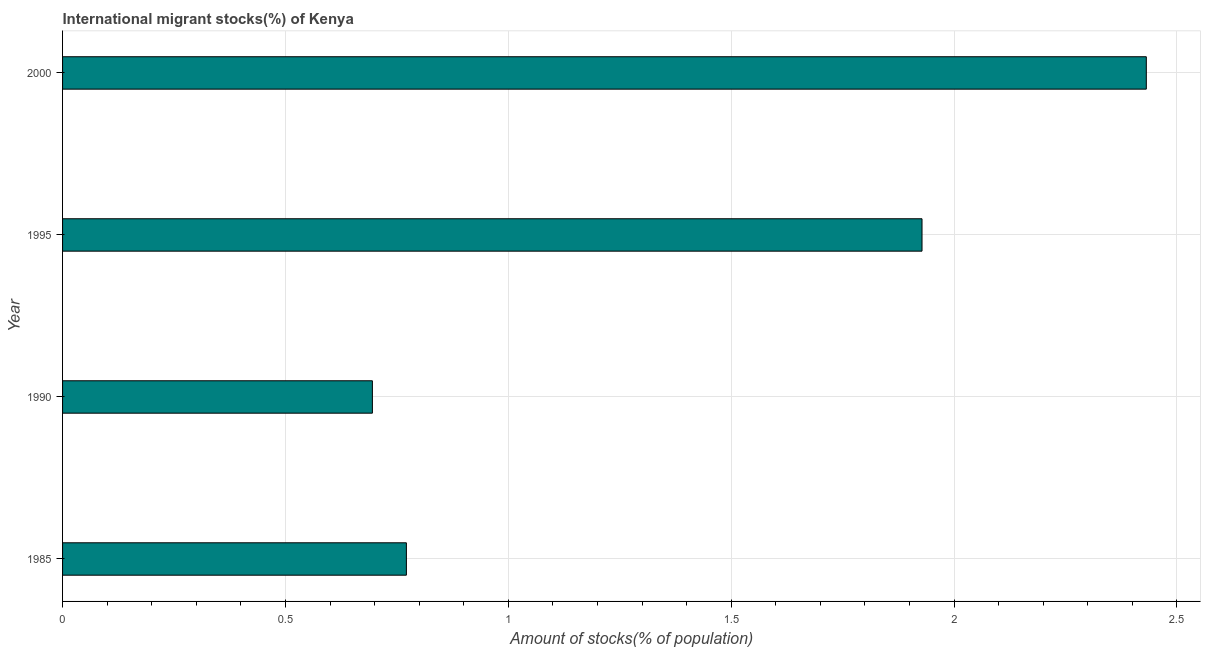Does the graph contain any zero values?
Keep it short and to the point. No. Does the graph contain grids?
Ensure brevity in your answer.  Yes. What is the title of the graph?
Offer a terse response. International migrant stocks(%) of Kenya. What is the label or title of the X-axis?
Ensure brevity in your answer.  Amount of stocks(% of population). What is the label or title of the Y-axis?
Provide a succinct answer. Year. What is the number of international migrant stocks in 1990?
Your answer should be compact. 0.7. Across all years, what is the maximum number of international migrant stocks?
Make the answer very short. 2.43. Across all years, what is the minimum number of international migrant stocks?
Keep it short and to the point. 0.7. In which year was the number of international migrant stocks maximum?
Make the answer very short. 2000. What is the sum of the number of international migrant stocks?
Provide a succinct answer. 5.83. What is the difference between the number of international migrant stocks in 1985 and 1995?
Offer a terse response. -1.16. What is the average number of international migrant stocks per year?
Offer a terse response. 1.46. What is the median number of international migrant stocks?
Make the answer very short. 1.35. In how many years, is the number of international migrant stocks greater than 2.3 %?
Offer a very short reply. 1. Do a majority of the years between 2000 and 1985 (inclusive) have number of international migrant stocks greater than 1.6 %?
Make the answer very short. Yes. What is the ratio of the number of international migrant stocks in 1985 to that in 1990?
Make the answer very short. 1.11. Is the number of international migrant stocks in 1985 less than that in 2000?
Ensure brevity in your answer.  Yes. What is the difference between the highest and the second highest number of international migrant stocks?
Make the answer very short. 0.5. Is the sum of the number of international migrant stocks in 1990 and 1995 greater than the maximum number of international migrant stocks across all years?
Your answer should be compact. Yes. What is the difference between the highest and the lowest number of international migrant stocks?
Your answer should be compact. 1.74. In how many years, is the number of international migrant stocks greater than the average number of international migrant stocks taken over all years?
Ensure brevity in your answer.  2. Are all the bars in the graph horizontal?
Make the answer very short. Yes. What is the Amount of stocks(% of population) in 1985?
Your answer should be very brief. 0.77. What is the Amount of stocks(% of population) in 1990?
Your answer should be very brief. 0.7. What is the Amount of stocks(% of population) in 1995?
Give a very brief answer. 1.93. What is the Amount of stocks(% of population) of 2000?
Make the answer very short. 2.43. What is the difference between the Amount of stocks(% of population) in 1985 and 1990?
Offer a very short reply. 0.08. What is the difference between the Amount of stocks(% of population) in 1985 and 1995?
Ensure brevity in your answer.  -1.16. What is the difference between the Amount of stocks(% of population) in 1985 and 2000?
Keep it short and to the point. -1.66. What is the difference between the Amount of stocks(% of population) in 1990 and 1995?
Provide a succinct answer. -1.23. What is the difference between the Amount of stocks(% of population) in 1990 and 2000?
Give a very brief answer. -1.74. What is the difference between the Amount of stocks(% of population) in 1995 and 2000?
Offer a very short reply. -0.5. What is the ratio of the Amount of stocks(% of population) in 1985 to that in 1990?
Ensure brevity in your answer.  1.11. What is the ratio of the Amount of stocks(% of population) in 1985 to that in 1995?
Offer a very short reply. 0.4. What is the ratio of the Amount of stocks(% of population) in 1985 to that in 2000?
Keep it short and to the point. 0.32. What is the ratio of the Amount of stocks(% of population) in 1990 to that in 1995?
Your response must be concise. 0.36. What is the ratio of the Amount of stocks(% of population) in 1990 to that in 2000?
Ensure brevity in your answer.  0.29. What is the ratio of the Amount of stocks(% of population) in 1995 to that in 2000?
Ensure brevity in your answer.  0.79. 